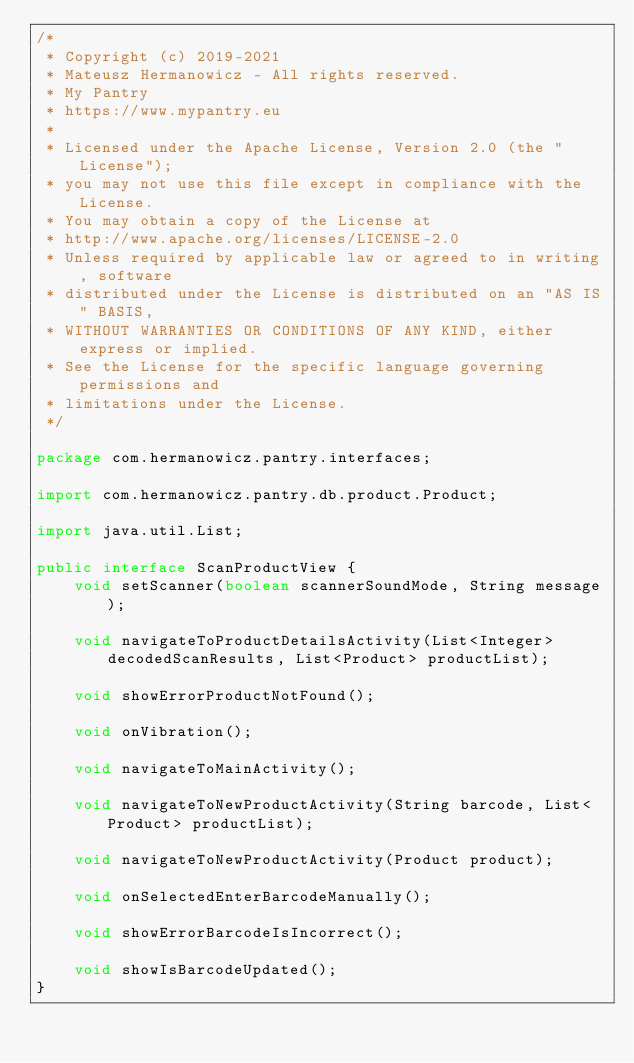<code> <loc_0><loc_0><loc_500><loc_500><_Java_>/*
 * Copyright (c) 2019-2021
 * Mateusz Hermanowicz - All rights reserved.
 * My Pantry
 * https://www.mypantry.eu
 *
 * Licensed under the Apache License, Version 2.0 (the "License");
 * you may not use this file except in compliance with the License.
 * You may obtain a copy of the License at
 * http://www.apache.org/licenses/LICENSE-2.0
 * Unless required by applicable law or agreed to in writing, software
 * distributed under the License is distributed on an "AS IS" BASIS,
 * WITHOUT WARRANTIES OR CONDITIONS OF ANY KIND, either express or implied.
 * See the License for the specific language governing permissions and
 * limitations under the License.
 */

package com.hermanowicz.pantry.interfaces;

import com.hermanowicz.pantry.db.product.Product;

import java.util.List;

public interface ScanProductView {
    void setScanner(boolean scannerSoundMode, String message);

    void navigateToProductDetailsActivity(List<Integer> decodedScanResults, List<Product> productList);

    void showErrorProductNotFound();

    void onVibration();

    void navigateToMainActivity();

    void navigateToNewProductActivity(String barcode, List<Product> productList);

    void navigateToNewProductActivity(Product product);

    void onSelectedEnterBarcodeManually();

    void showErrorBarcodeIsIncorrect();

    void showIsBarcodeUpdated();
}</code> 